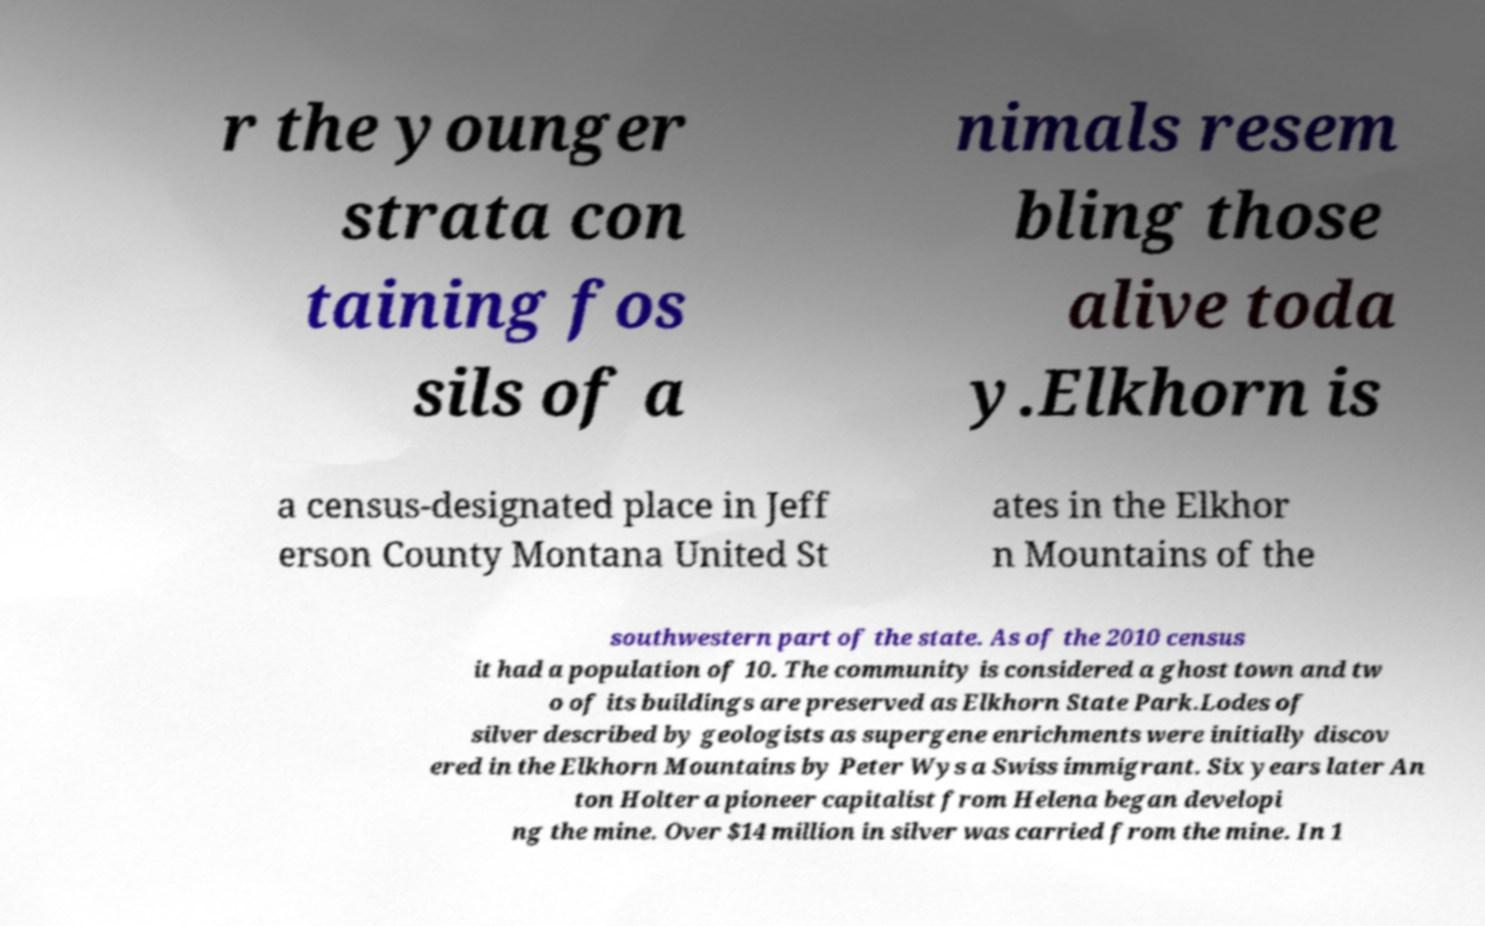What messages or text are displayed in this image? I need them in a readable, typed format. r the younger strata con taining fos sils of a nimals resem bling those alive toda y.Elkhorn is a census-designated place in Jeff erson County Montana United St ates in the Elkhor n Mountains of the southwestern part of the state. As of the 2010 census it had a population of 10. The community is considered a ghost town and tw o of its buildings are preserved as Elkhorn State Park.Lodes of silver described by geologists as supergene enrichments were initially discov ered in the Elkhorn Mountains by Peter Wys a Swiss immigrant. Six years later An ton Holter a pioneer capitalist from Helena began developi ng the mine. Over $14 million in silver was carried from the mine. In 1 